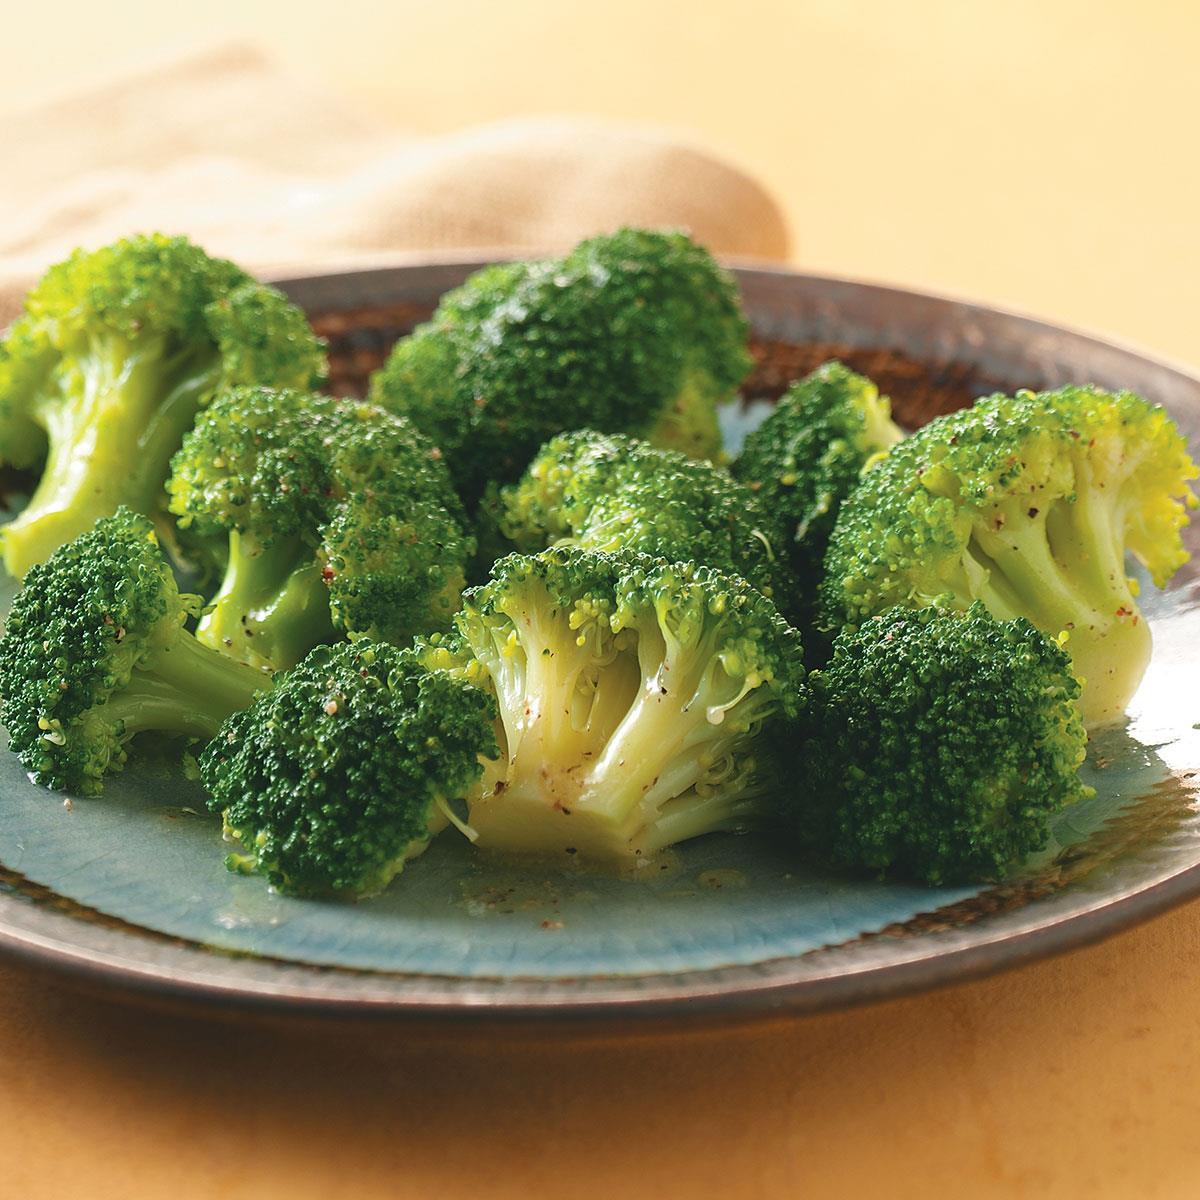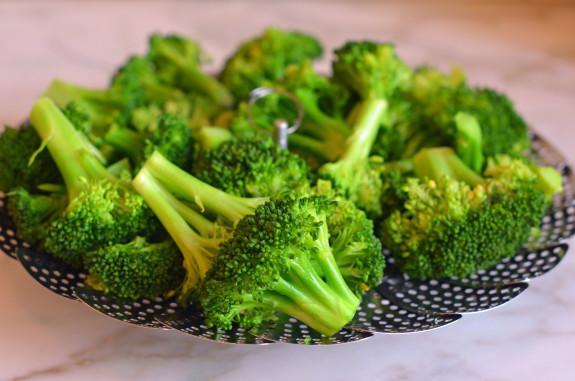The first image is the image on the left, the second image is the image on the right. For the images displayed, is the sentence "Right image shows broccoli in a deep container with water." factually correct? Answer yes or no. No. The first image is the image on the left, the second image is the image on the right. Considering the images on both sides, is "One photo features a container made of metal." valid? Answer yes or no. No. 